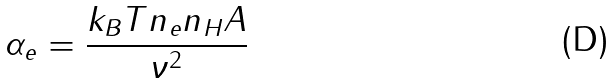Convert formula to latex. <formula><loc_0><loc_0><loc_500><loc_500>\alpha _ { e } = \frac { k _ { B } T n _ { e } n _ { H } A } { \nu ^ { 2 } }</formula> 